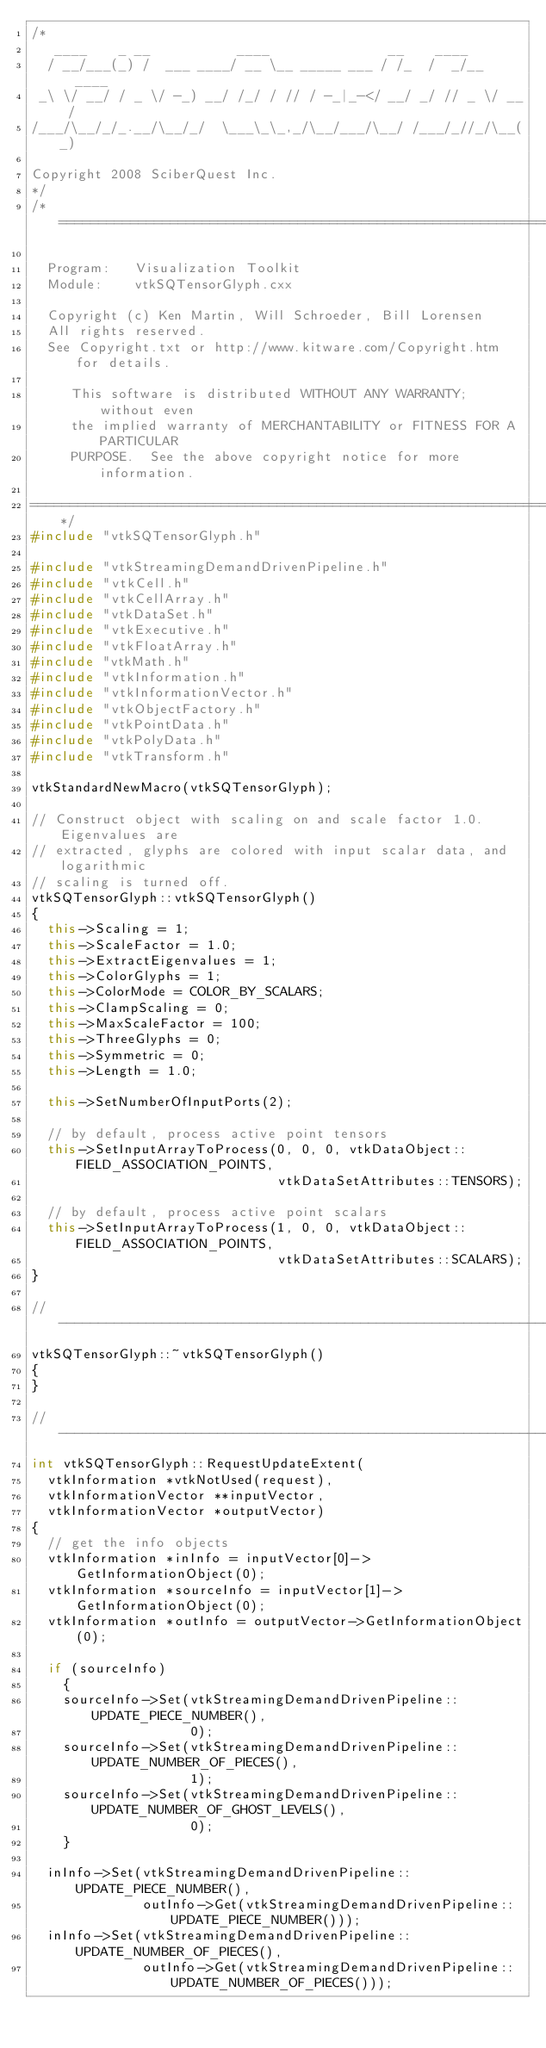<code> <loc_0><loc_0><loc_500><loc_500><_C++_>/*
   ____    _ __           ____               __    ____
  / __/___(_) /  ___ ____/ __ \__ _____ ___ / /_  /  _/__  ____
 _\ \/ __/ / _ \/ -_) __/ /_/ / // / -_|_-</ __/ _/ // _ \/ __/
/___/\__/_/_.__/\__/_/  \___\_\_,_/\__/___/\__/ /___/_//_/\__(_)

Copyright 2008 SciberQuest Inc.
*/
/*=========================================================================

  Program:   Visualization Toolkit
  Module:    vtkSQTensorGlyph.cxx

  Copyright (c) Ken Martin, Will Schroeder, Bill Lorensen
  All rights reserved.
  See Copyright.txt or http://www.kitware.com/Copyright.htm for details.

     This software is distributed WITHOUT ANY WARRANTY; without even
     the implied warranty of MERCHANTABILITY or FITNESS FOR A PARTICULAR
     PURPOSE.  See the above copyright notice for more information.

=========================================================================*/
#include "vtkSQTensorGlyph.h"

#include "vtkStreamingDemandDrivenPipeline.h"
#include "vtkCell.h"
#include "vtkCellArray.h"
#include "vtkDataSet.h"
#include "vtkExecutive.h"
#include "vtkFloatArray.h"
#include "vtkMath.h"
#include "vtkInformation.h"
#include "vtkInformationVector.h"
#include "vtkObjectFactory.h"
#include "vtkPointData.h"
#include "vtkPolyData.h"
#include "vtkTransform.h"

vtkStandardNewMacro(vtkSQTensorGlyph);

// Construct object with scaling on and scale factor 1.0. Eigenvalues are 
// extracted, glyphs are colored with input scalar data, and logarithmic
// scaling is turned off.
vtkSQTensorGlyph::vtkSQTensorGlyph()
{
  this->Scaling = 1;
  this->ScaleFactor = 1.0;
  this->ExtractEigenvalues = 1;
  this->ColorGlyphs = 1;
  this->ColorMode = COLOR_BY_SCALARS;
  this->ClampScaling = 0;
  this->MaxScaleFactor = 100;
  this->ThreeGlyphs = 0;
  this->Symmetric = 0;
  this->Length = 1.0;

  this->SetNumberOfInputPorts(2);

  // by default, process active point tensors
  this->SetInputArrayToProcess(0, 0, 0, vtkDataObject::FIELD_ASSOCIATION_POINTS,
                               vtkDataSetAttributes::TENSORS);

  // by default, process active point scalars
  this->SetInputArrayToProcess(1, 0, 0, vtkDataObject::FIELD_ASSOCIATION_POINTS,
                               vtkDataSetAttributes::SCALARS);
}

//----------------------------------------------------------------------------
vtkSQTensorGlyph::~vtkSQTensorGlyph()
{
}

//----------------------------------------------------------------------------
int vtkSQTensorGlyph::RequestUpdateExtent(
  vtkInformation *vtkNotUsed(request),
  vtkInformationVector **inputVector,
  vtkInformationVector *outputVector)
{
  // get the info objects
  vtkInformation *inInfo = inputVector[0]->GetInformationObject(0);
  vtkInformation *sourceInfo = inputVector[1]->GetInformationObject(0);
  vtkInformation *outInfo = outputVector->GetInformationObject(0);

  if (sourceInfo)
    {
    sourceInfo->Set(vtkStreamingDemandDrivenPipeline::UPDATE_PIECE_NUMBER(),
                    0);
    sourceInfo->Set(vtkStreamingDemandDrivenPipeline::UPDATE_NUMBER_OF_PIECES(),
                    1);
    sourceInfo->Set(vtkStreamingDemandDrivenPipeline::UPDATE_NUMBER_OF_GHOST_LEVELS(),
                    0);
    }

  inInfo->Set(vtkStreamingDemandDrivenPipeline::UPDATE_PIECE_NUMBER(),
              outInfo->Get(vtkStreamingDemandDrivenPipeline::UPDATE_PIECE_NUMBER()));
  inInfo->Set(vtkStreamingDemandDrivenPipeline::UPDATE_NUMBER_OF_PIECES(),
              outInfo->Get(vtkStreamingDemandDrivenPipeline::UPDATE_NUMBER_OF_PIECES()));</code> 